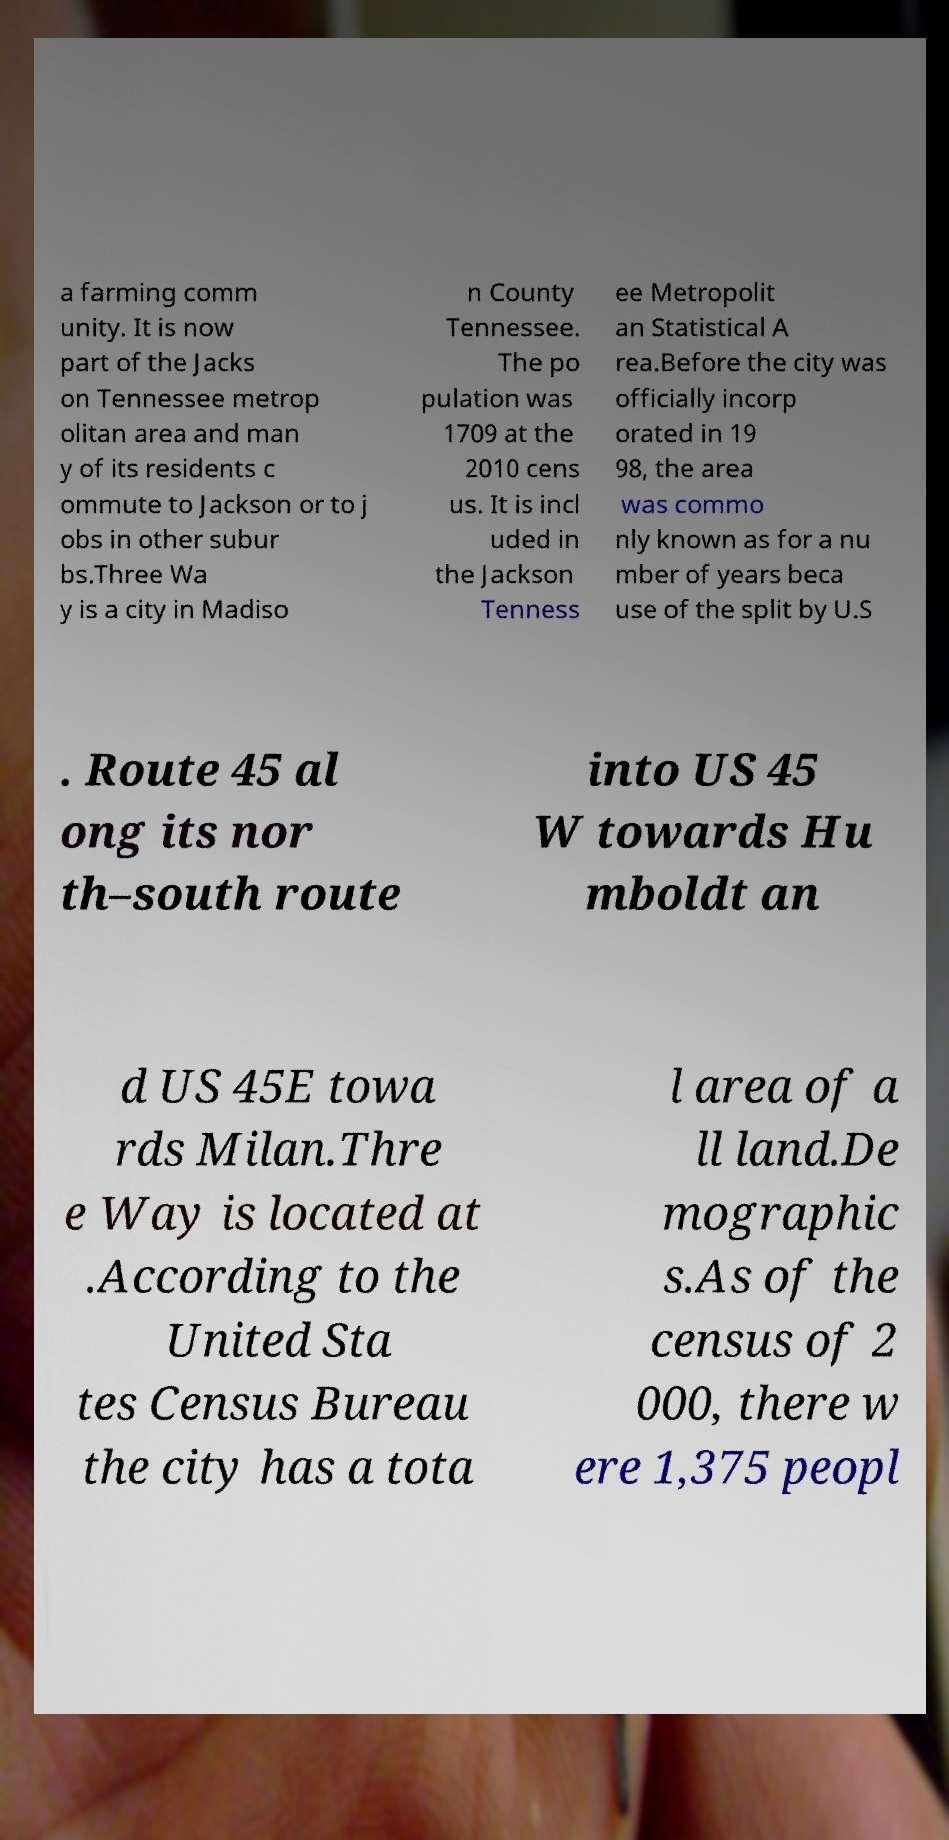Can you accurately transcribe the text from the provided image for me? a farming comm unity. It is now part of the Jacks on Tennessee metrop olitan area and man y of its residents c ommute to Jackson or to j obs in other subur bs.Three Wa y is a city in Madiso n County Tennessee. The po pulation was 1709 at the 2010 cens us. It is incl uded in the Jackson Tenness ee Metropolit an Statistical A rea.Before the city was officially incorp orated in 19 98, the area was commo nly known as for a nu mber of years beca use of the split by U.S . Route 45 al ong its nor th–south route into US 45 W towards Hu mboldt an d US 45E towa rds Milan.Thre e Way is located at .According to the United Sta tes Census Bureau the city has a tota l area of a ll land.De mographic s.As of the census of 2 000, there w ere 1,375 peopl 